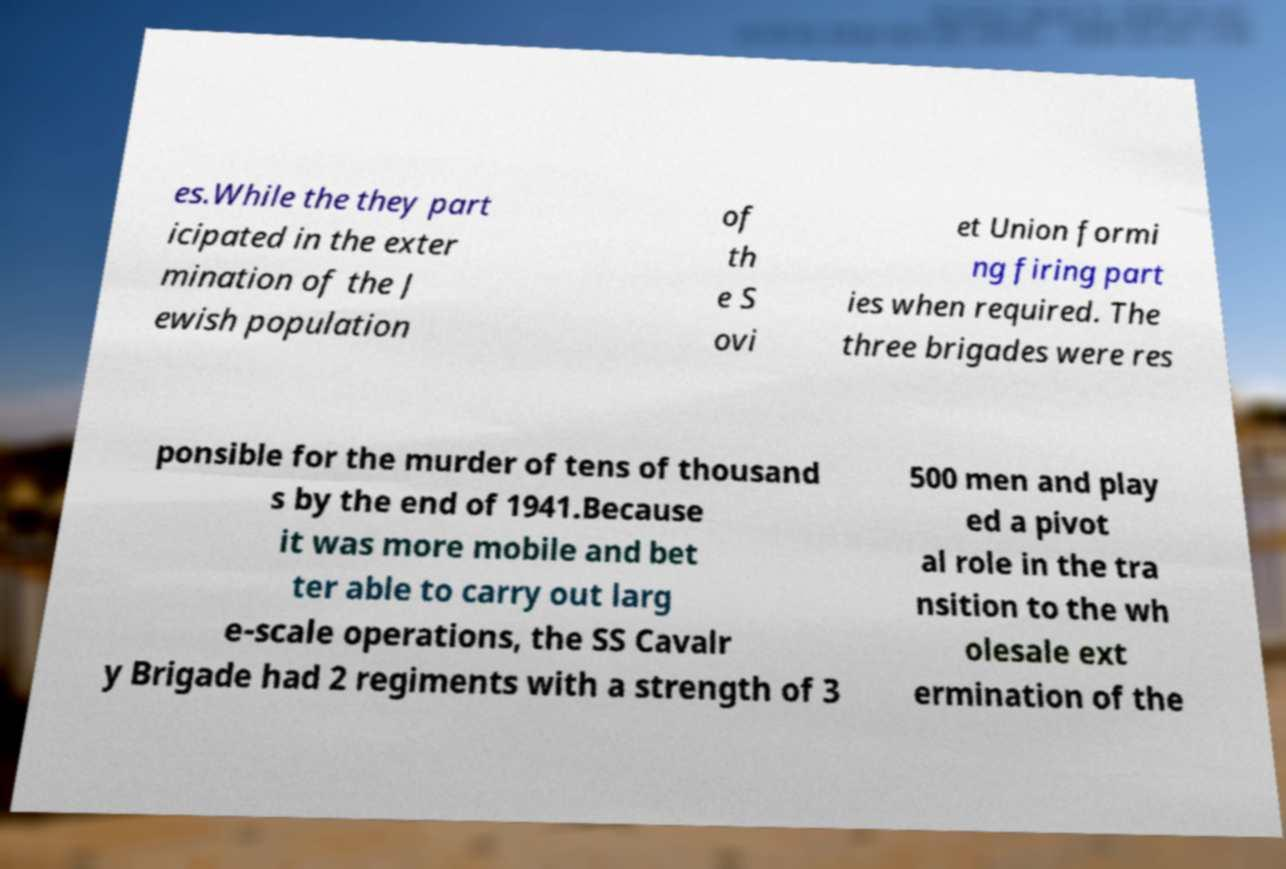There's text embedded in this image that I need extracted. Can you transcribe it verbatim? es.While the they part icipated in the exter mination of the J ewish population of th e S ovi et Union formi ng firing part ies when required. The three brigades were res ponsible for the murder of tens of thousand s by the end of 1941.Because it was more mobile and bet ter able to carry out larg e-scale operations, the SS Cavalr y Brigade had 2 regiments with a strength of 3 500 men and play ed a pivot al role in the tra nsition to the wh olesale ext ermination of the 